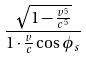<formula> <loc_0><loc_0><loc_500><loc_500>\frac { \sqrt { 1 - \frac { v ^ { 5 } } { c ^ { 5 } } } } { 1 \cdot \frac { v } { c } \cos \phi _ { s } }</formula> 